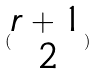Convert formula to latex. <formula><loc_0><loc_0><loc_500><loc_500>( \begin{matrix} r + 1 \\ 2 \end{matrix} )</formula> 